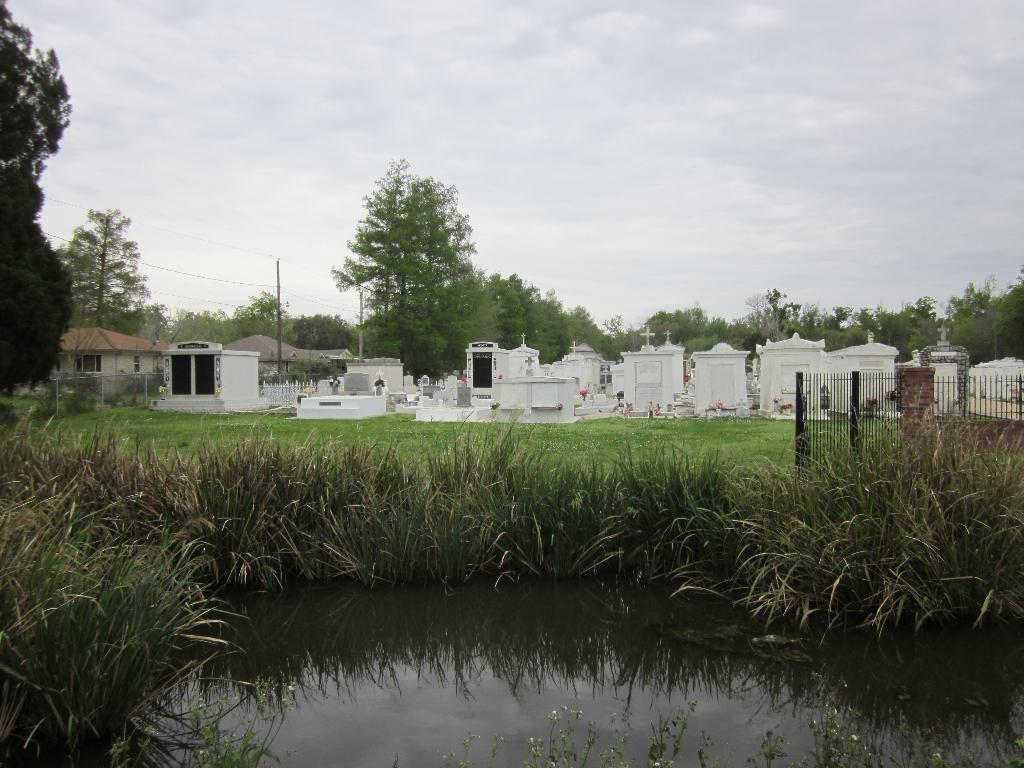What type of location is depicted in the image? There is a graveyard in the image. What natural elements can be seen in the image? There are trees, water, and grass visible in the image. What is visible in the background of the image? The sky is visible in the background of the image. What type of bed is present in the image? There is no bed present in the image; it depicts a graveyard with natural elements and the sky in the background. 